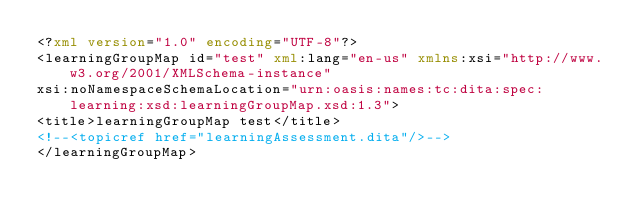<code> <loc_0><loc_0><loc_500><loc_500><_XML_><?xml version="1.0" encoding="UTF-8"?>
<learningGroupMap id="test" xml:lang="en-us" xmlns:xsi="http://www.w3.org/2001/XMLSchema-instance"
xsi:noNamespaceSchemaLocation="urn:oasis:names:tc:dita:spec:learning:xsd:learningGroupMap.xsd:1.3">
<title>learningGroupMap test</title>
<!--<topicref href="learningAssessment.dita"/>-->
</learningGroupMap>
</code> 